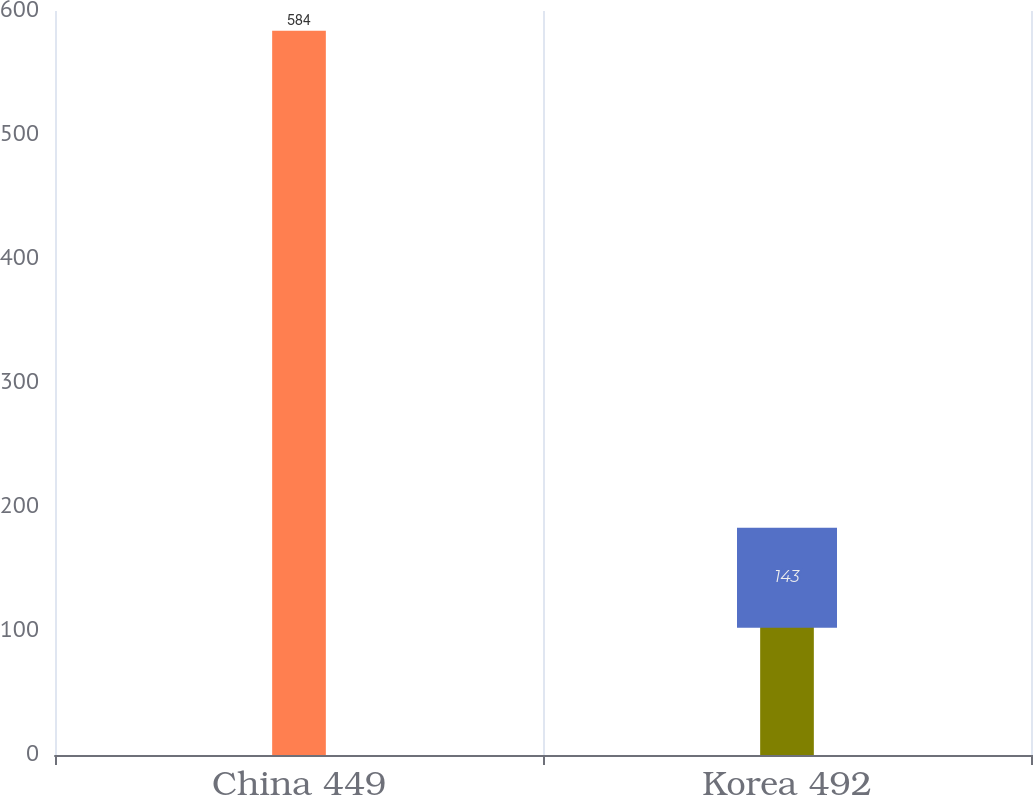Convert chart. <chart><loc_0><loc_0><loc_500><loc_500><bar_chart><fcel>China 449<fcel>Korea 492<nl><fcel>584<fcel>143<nl></chart> 